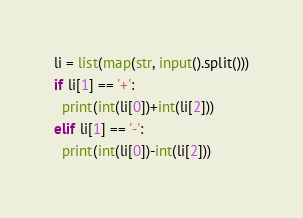Convert code to text. <code><loc_0><loc_0><loc_500><loc_500><_Python_>li = list(map(str, input().split()))
if li[1] == '+':
  print(int(li[0])+int(li[2]))
elif li[1] == '-':
  print(int(li[0])-int(li[2]))</code> 